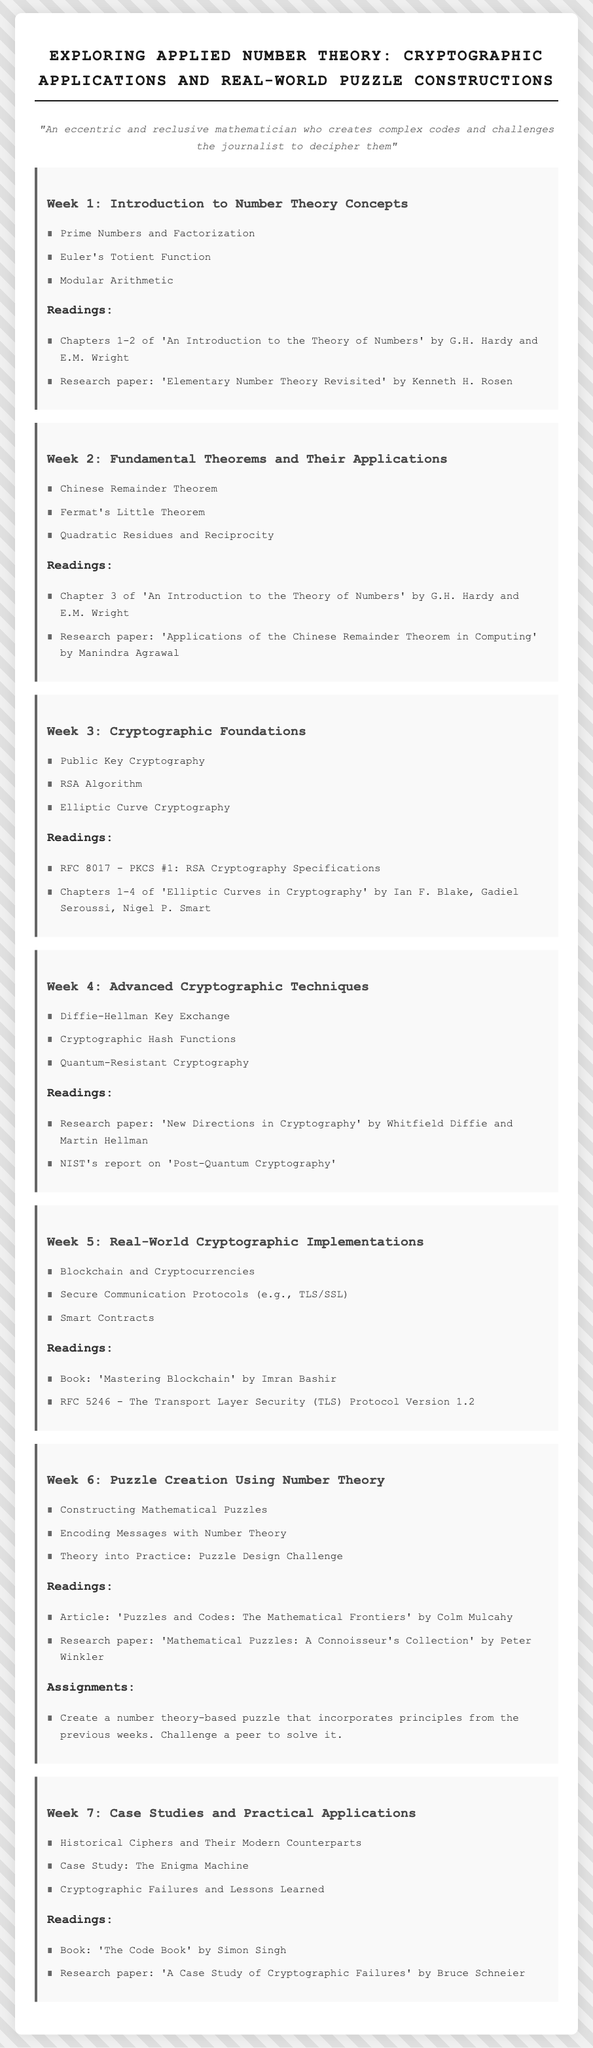What is the title of the syllabus? The title is prominently displayed at the top of the document.
Answer: Exploring Applied Number Theory: Cryptographic Applications and Real-World Puzzle Constructions Who are the authors of 'An Introduction to the Theory of Numbers'? This information is mentioned in the readings for Week 1 of the syllabus.
Answer: G.H. Hardy and E.M. Wright What theorem is studied in Week 2 that involves modular arithmetic? This information can be found in the list of topics covered in Week 2.
Answer: Chinese Remainder Theorem Which cryptographic algorithm is introduced in Week 3? This information is available in the list of topics for Week 3.
Answer: RSA Algorithm What is one of the readings for Week 6? The readings for Week 6 are listed under that week.
Answer: 'Puzzles and Codes: The Mathematical Frontiers' How many weeks are covered in the syllabus? The number of weeks is determined by counting the week sections present in the document.
Answer: 7 What is the assignment for Week 6? This information can be found in the assignments listed under Week 6.
Answer: Create a number theory-based puzzle that incorporates principles from the previous weeks. Challenge a peer to solve it Which book is recommended for Week 7? This information can be found in the readings for Week 7.
Answer: 'The Code Book' by Simon Singh What is the focus of Week 5? The main topics are listed for Week 5.
Answer: Real-World Cryptographic Implementations 